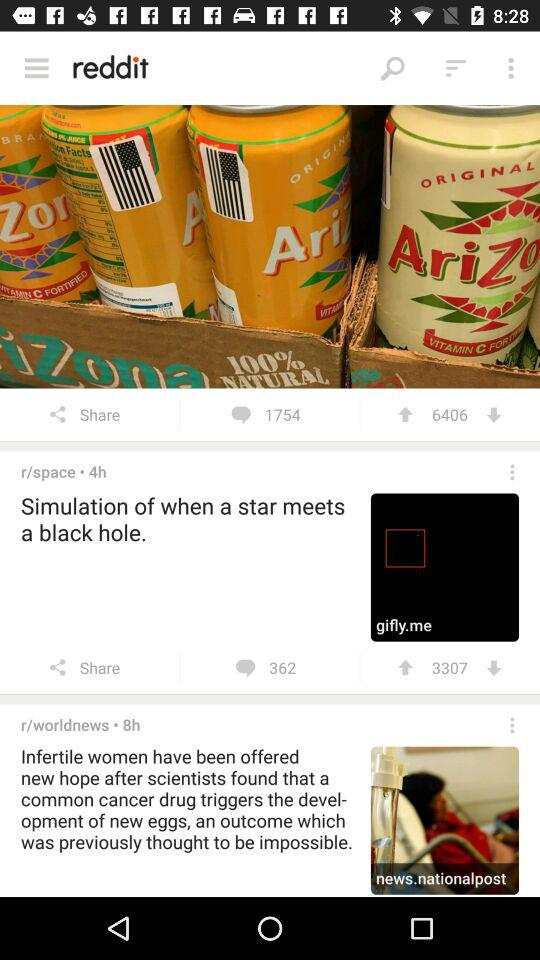What is the total number of comments on the space post? The total number of comments is 362. 